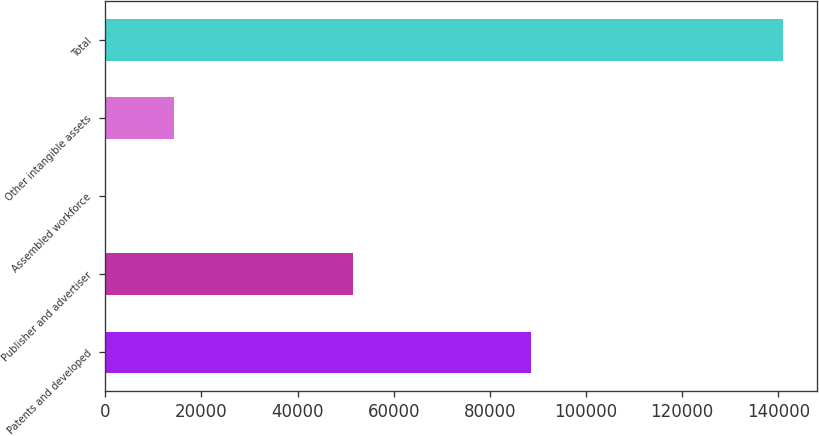Convert chart to OTSL. <chart><loc_0><loc_0><loc_500><loc_500><bar_chart><fcel>Patents and developed<fcel>Publisher and advertiser<fcel>Assembled workforce<fcel>Other intangible assets<fcel>Total<nl><fcel>88453<fcel>51497<fcel>246<fcel>14322.9<fcel>141015<nl></chart> 